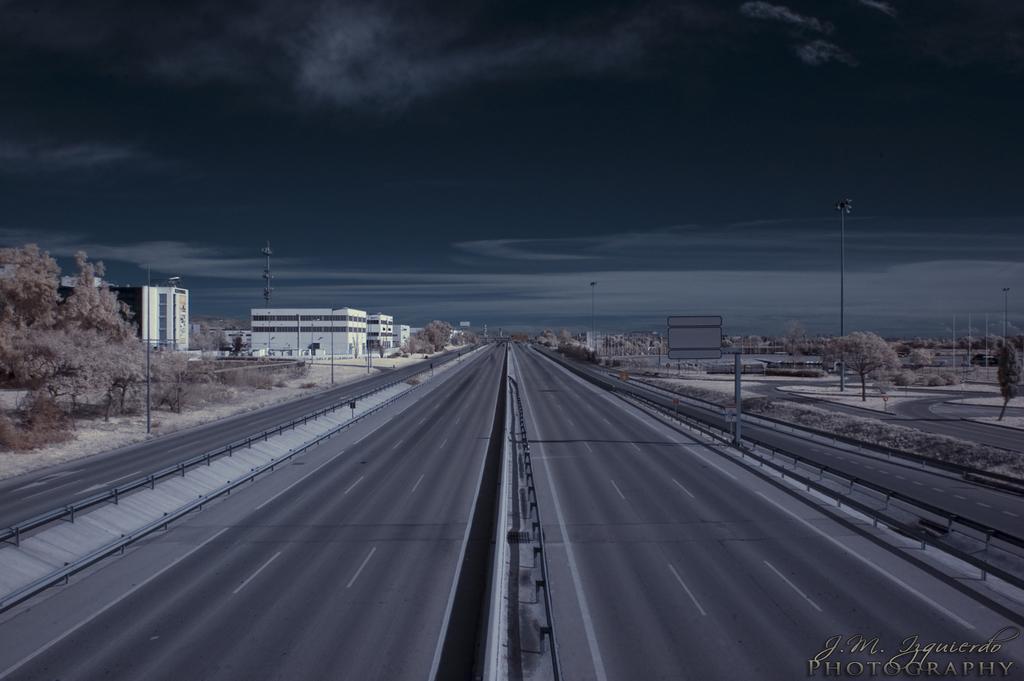Can you describe this image briefly? In this image we can see the pathways. We can also see the poles, a tower, a signboard, a group of trees, buildings, plants and the sky which looks cloudy. 